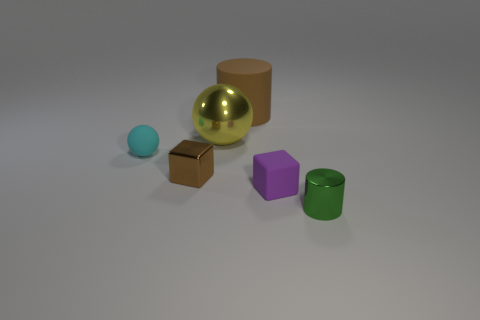Which object in this image appears to be the largest? The gold sphere appears to be the largest object in the image. 